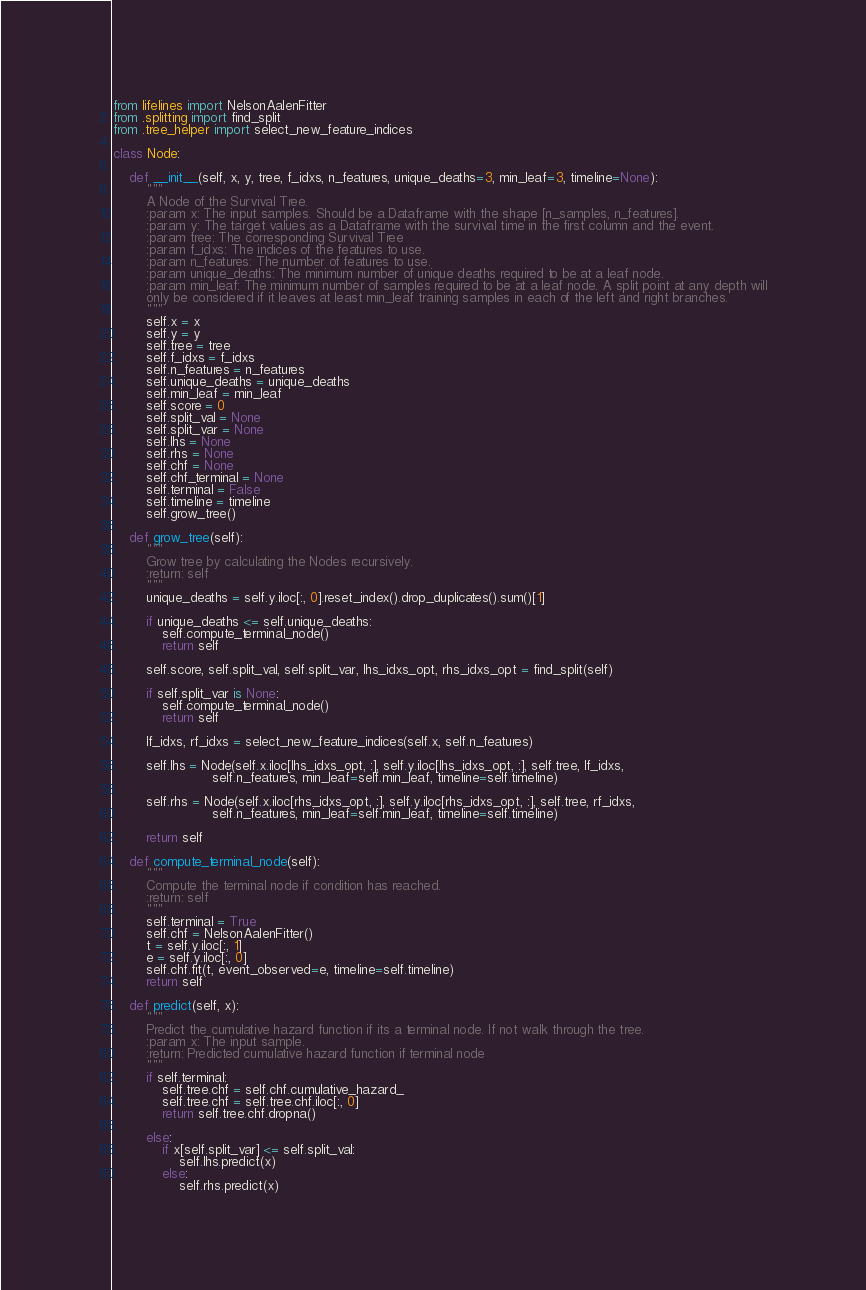<code> <loc_0><loc_0><loc_500><loc_500><_Python_>from lifelines import NelsonAalenFitter
from .splitting import find_split
from .tree_helper import select_new_feature_indices

class Node:

    def __init__(self, x, y, tree, f_idxs, n_features, unique_deaths=3, min_leaf=3, timeline=None):
        """
        A Node of the Survival Tree.
        :param x: The input samples. Should be a Dataframe with the shape [n_samples, n_features].
        :param y: The target values as a Dataframe with the survival time in the first column and the event.
        :param tree: The corresponding Survival Tree
        :param f_idxs: The indices of the features to use.
        :param n_features: The number of features to use.
        :param unique_deaths: The minimum number of unique deaths required to be at a leaf node.
        :param min_leaf: The minimum number of samples required to be at a leaf node. A split point at any depth will
        only be considered if it leaves at least min_leaf training samples in each of the left and right branches.
        """
        self.x = x
        self.y = y
        self.tree = tree
        self.f_idxs = f_idxs
        self.n_features = n_features
        self.unique_deaths = unique_deaths
        self.min_leaf = min_leaf
        self.score = 0
        self.split_val = None
        self.split_var = None
        self.lhs = None
        self.rhs = None
        self.chf = None
        self.chf_terminal = None
        self.terminal = False
        self.timeline = timeline
        self.grow_tree()

    def grow_tree(self):
        """
        Grow tree by calculating the Nodes recursively.
        :return: self
        """
        unique_deaths = self.y.iloc[:, 0].reset_index().drop_duplicates().sum()[1]

        if unique_deaths <= self.unique_deaths:
            self.compute_terminal_node()
            return self

        self.score, self.split_val, self.split_var, lhs_idxs_opt, rhs_idxs_opt = find_split(self)

        if self.split_var is None:
            self.compute_terminal_node()
            return self

        lf_idxs, rf_idxs = select_new_feature_indices(self.x, self.n_features)

        self.lhs = Node(self.x.iloc[lhs_idxs_opt, :], self.y.iloc[lhs_idxs_opt, :], self.tree, lf_idxs,
                        self.n_features, min_leaf=self.min_leaf, timeline=self.timeline)

        self.rhs = Node(self.x.iloc[rhs_idxs_opt, :], self.y.iloc[rhs_idxs_opt, :], self.tree, rf_idxs,
                        self.n_features, min_leaf=self.min_leaf, timeline=self.timeline)

        return self

    def compute_terminal_node(self):
        """
        Compute the terminal node if condition has reached.
        :return: self
        """
        self.terminal = True
        self.chf = NelsonAalenFitter()
        t = self.y.iloc[:, 1]
        e = self.y.iloc[:, 0]
        self.chf.fit(t, event_observed=e, timeline=self.timeline)
        return self

    def predict(self, x):
        """
        Predict the cumulative hazard function if its a terminal node. If not walk through the tree.
        :param x: The input sample.
        :return: Predicted cumulative hazard function if terminal node
        """
        if self.terminal:
            self.tree.chf = self.chf.cumulative_hazard_
            self.tree.chf = self.tree.chf.iloc[:, 0]
            return self.tree.chf.dropna()

        else:
            if x[self.split_var] <= self.split_val:
                self.lhs.predict(x)
            else:
                self.rhs.predict(x)
</code> 